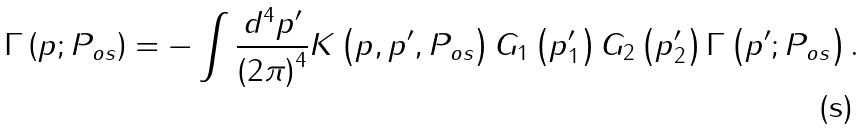<formula> <loc_0><loc_0><loc_500><loc_500>\Gamma \left ( p ; P _ { o s } \right ) = - \int \frac { d ^ { 4 } p ^ { \prime } } { \left ( 2 \pi \right ) ^ { 4 } } K \left ( p , p ^ { \prime } , P _ { o s } \right ) G _ { 1 } \left ( p _ { 1 } ^ { \prime } \right ) G _ { 2 } \left ( p _ { 2 } ^ { \prime } \right ) \Gamma \left ( p ^ { \prime } ; P _ { o s } \right ) .</formula> 